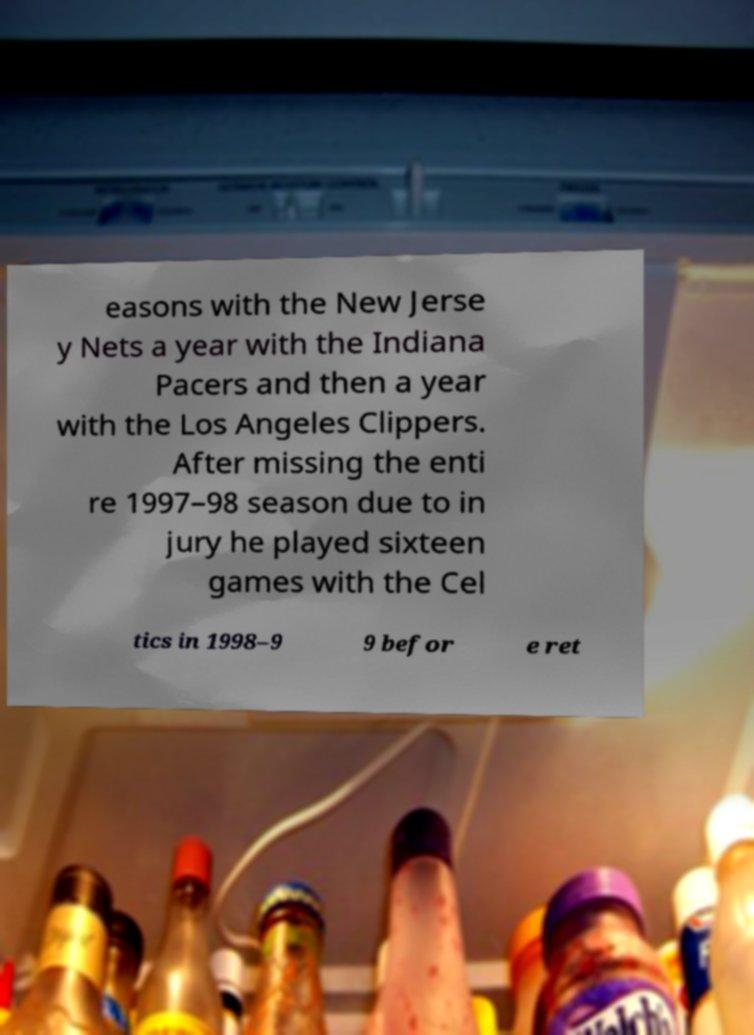Please identify and transcribe the text found in this image. easons with the New Jerse y Nets a year with the Indiana Pacers and then a year with the Los Angeles Clippers. After missing the enti re 1997–98 season due to in jury he played sixteen games with the Cel tics in 1998–9 9 befor e ret 